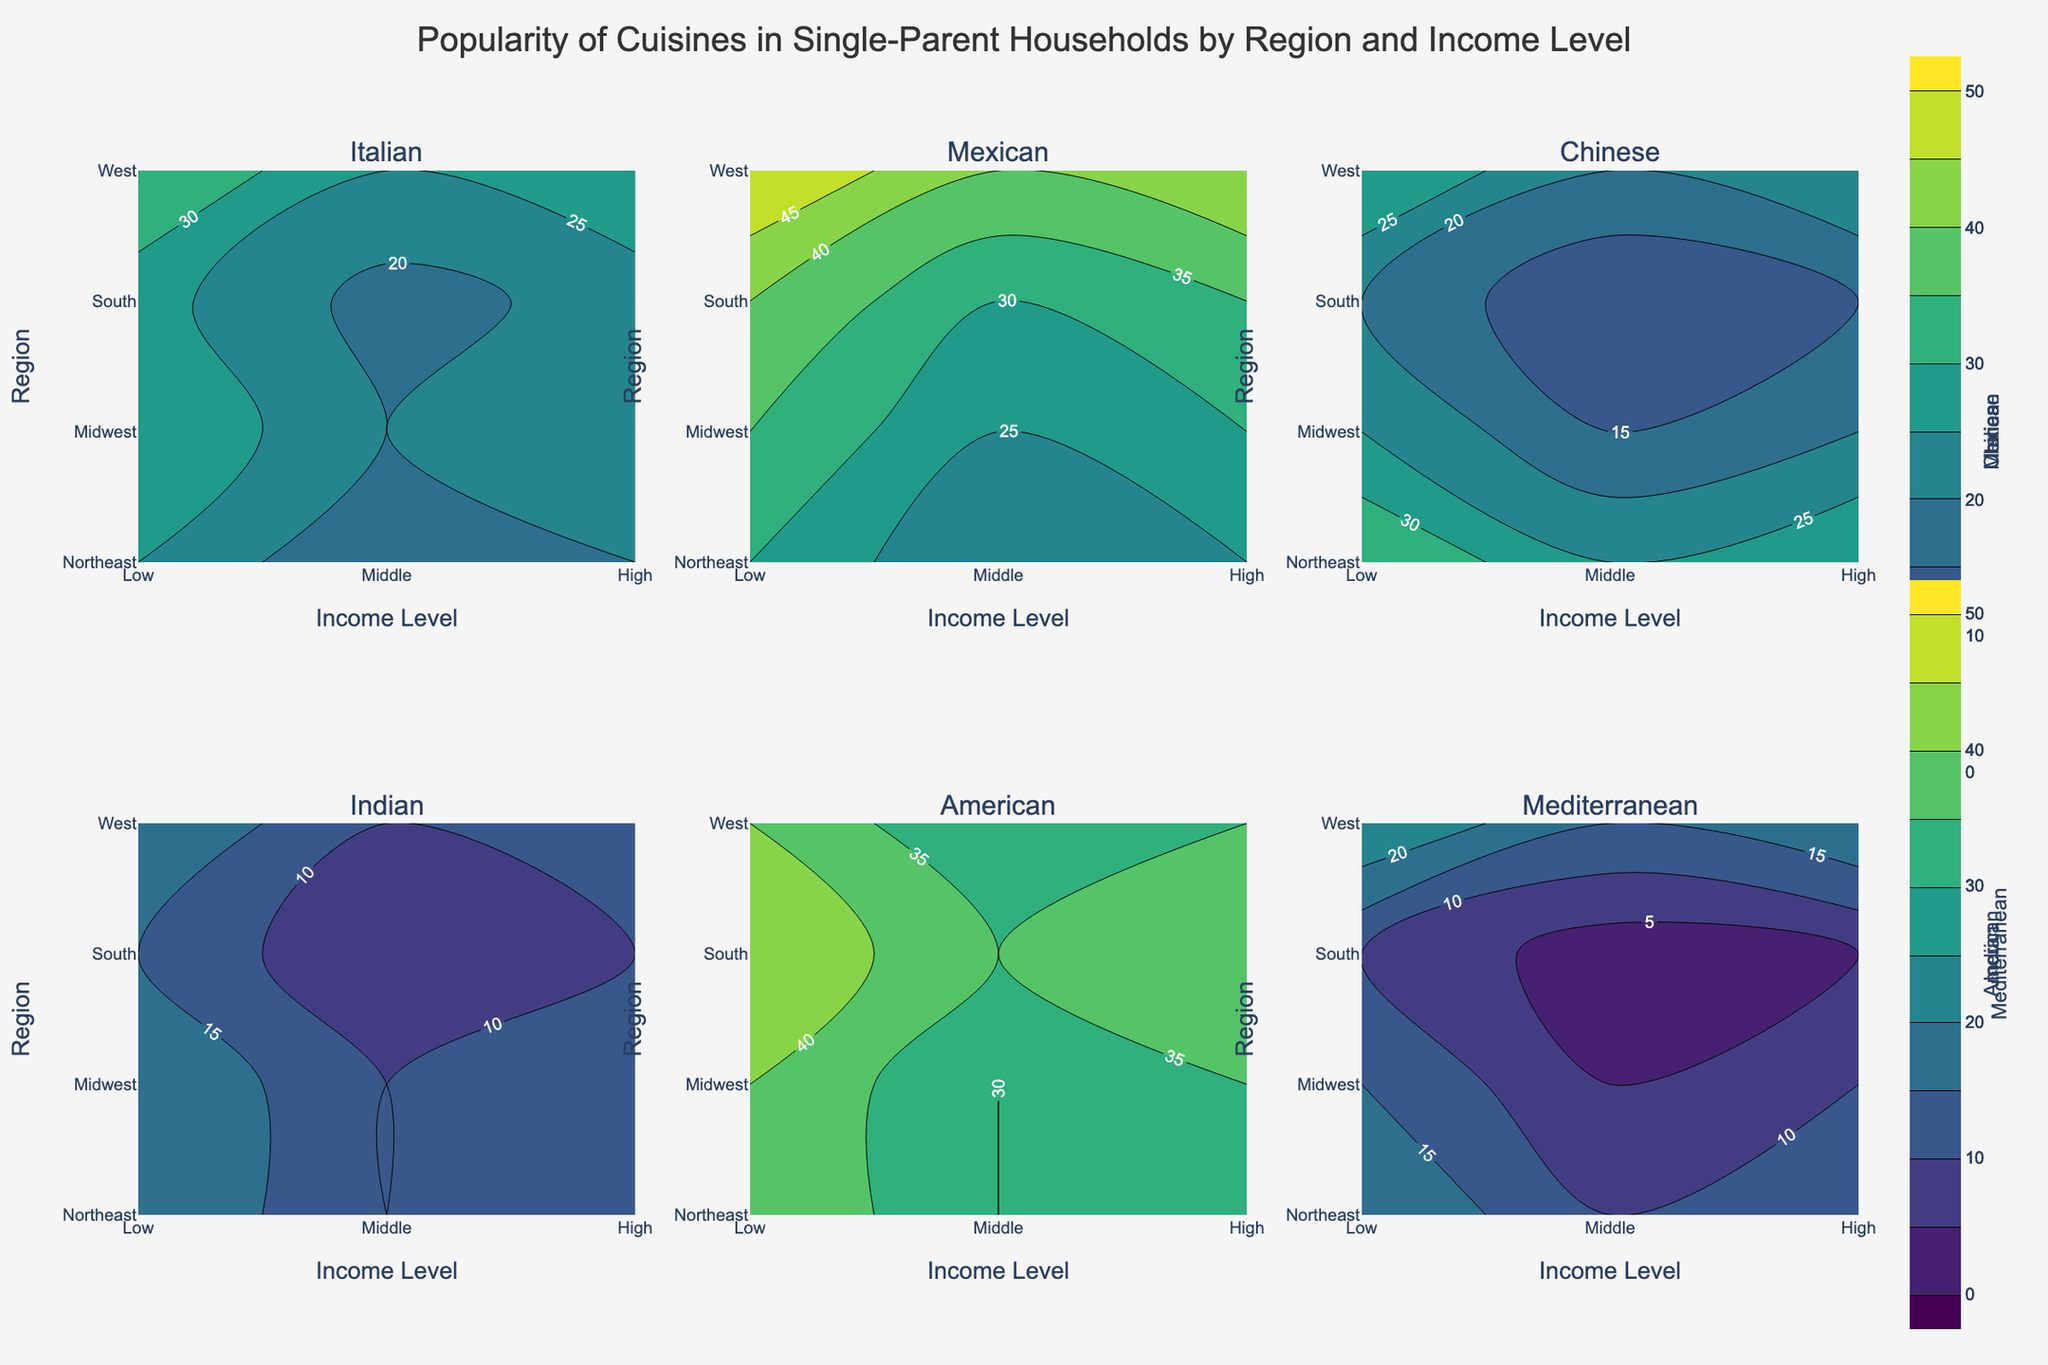What is the highest popularity value for Mexican cuisine in the West region? We look at the contour plot for Mexican cuisine, locate the West region on the y-axis, and identify the highest value.
Answer: 50 Which region has the least popularity for Indian cuisine at the low-income level? Check the contour plot for Indian cuisine, find the low-income level on the x-axis, and identify the region with the smallest value.
Answer: South What is the difference in popularity of American cuisine between high and low-income levels in the Midwest region? Compare the values at high and low-income levels in the Midwest region for the American cuisine plot.
Answer: 10 How does the popularity of Italian cuisine in the Northeast differ between middle and high-income levels? Check the difference between middle and high-income levels in the Northeast region from the Italian cuisine plot.
Answer: 5 Which cuisine has the least variation in popularity across all regions and income levels? Evaluate the contour plots for all cuisines and look for the one with the least spread or changes in values.
Answer: Mediterranean In which region and for which income level is the popularity of Chinese cuisine the highest? Look at the Chinese cuisine plot, find the peak value and note the corresponding region and income level.
Answer: Midwest, High Compare the popularity of Mexican cuisine between the Northeast and South for middle-income households. Identify the middle-income level on the Mexican cuisine plot and compare values between Northeast and South regions.
Answer: South > Northeast What is the average popularity of Mediterranean cuisine in high-income households across all regions? Sum the values of Mediterranean cuisine at high-income level for all regions and divide by the number of regions.
Answer: (15 + 20 + 10 + 25)/4 = 17.5 How does the popularity of Italian cuisine change from low to high-income levels in the West? Observe the Italian cuisine plot, note the values for low and high-income levels in the West region, and find the difference.
Answer: 10 Are there more regions with a high popularity of Mexican cuisine or Chinese cuisine for middle-income households? Compare the contour values for middle-income households across regions for Mexican and Chinese cuisines and count the ones with higher values (above 30 for this scenario).
Answer: Mexican 